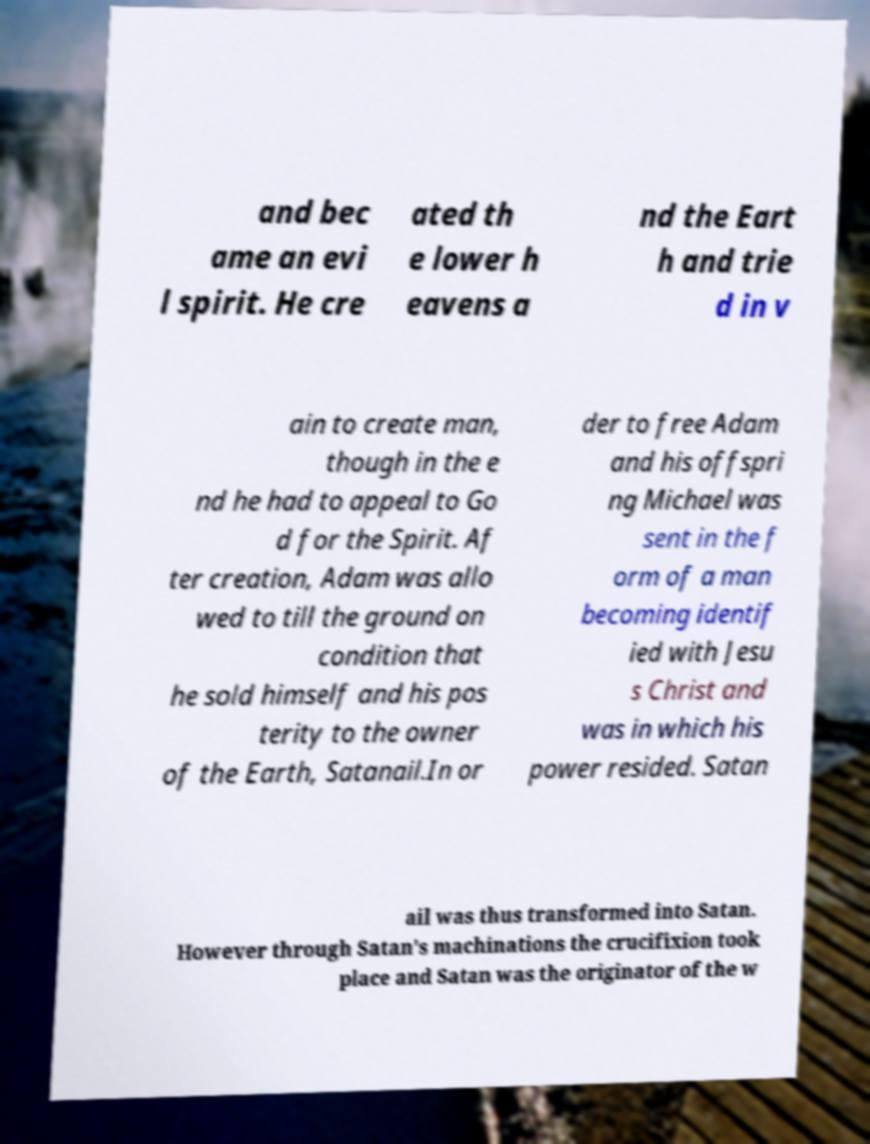Could you extract and type out the text from this image? and bec ame an evi l spirit. He cre ated th e lower h eavens a nd the Eart h and trie d in v ain to create man, though in the e nd he had to appeal to Go d for the Spirit. Af ter creation, Adam was allo wed to till the ground on condition that he sold himself and his pos terity to the owner of the Earth, Satanail.In or der to free Adam and his offspri ng Michael was sent in the f orm of a man becoming identif ied with Jesu s Christ and was in which his power resided. Satan ail was thus transformed into Satan. However through Satan's machinations the crucifixion took place and Satan was the originator of the w 